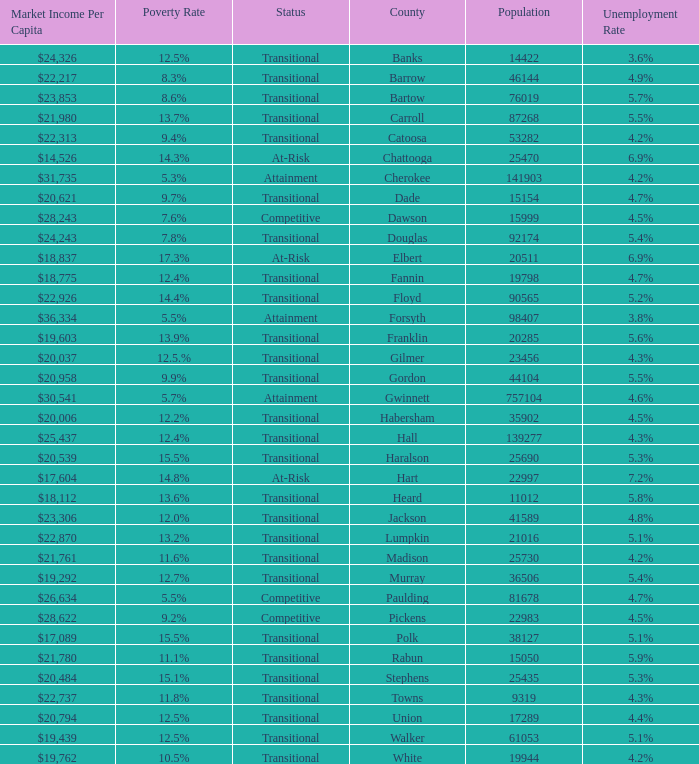What is the market income per capita of the county with the 9.4% poverty rate? $22,313. 